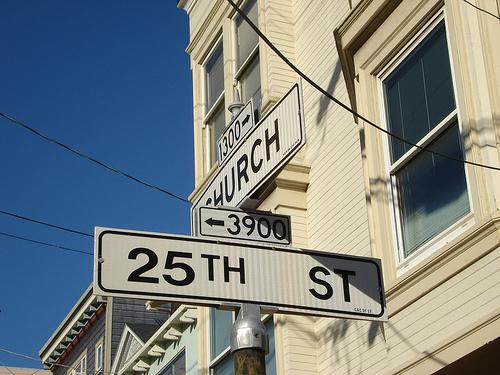Question: where is the photo taken?
Choices:
A. On the sidewalk.
B. On the street.
C. On a bridge.
D. At an intersection.
Answer with the letter. Answer: D Question: what are the signs on?
Choices:
A. Building.
B. Car.
C. The pole.
D. Billboard.
Answer with the letter. Answer: C Question: why is it so bright?
Choices:
A. Spotlight.
B. Sun light.
C. Moonlight.
D. Bright bulb.
Answer with the letter. Answer: B Question: how many signs are there?
Choices:
A. Six.
B. Three.
C. One.
D. Four.
Answer with the letter. Answer: D 